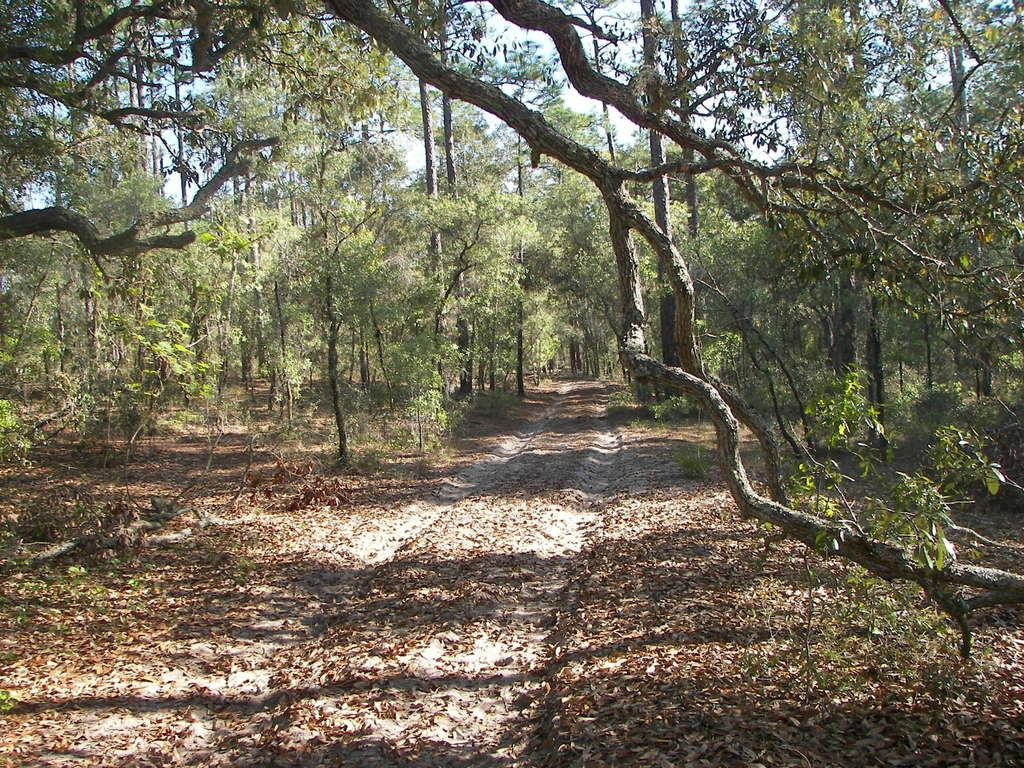What can be seen running through the trees in the image? There is a path in the image that runs between trees. What is the ground surface like along the path? Dry leaves are present on the ground in the image. What is the fifth unit of the plot in the image? There is no plot or units mentioned in the image; it only shows a path between trees with dry leaves on the ground. 